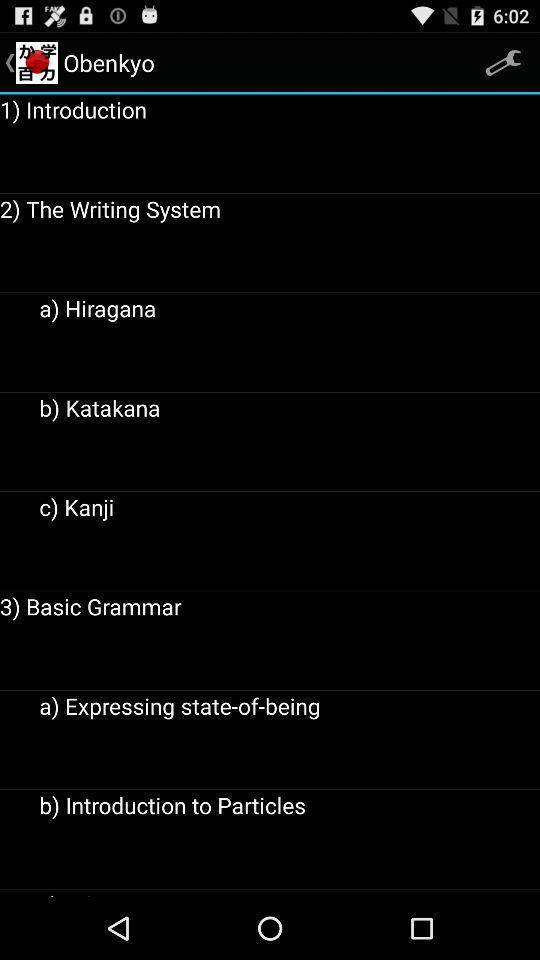What are the subheadings of "The Writing System"? The subheadings of "The Writing System" are "Hiragana", "Katakana" and "Kanji". 